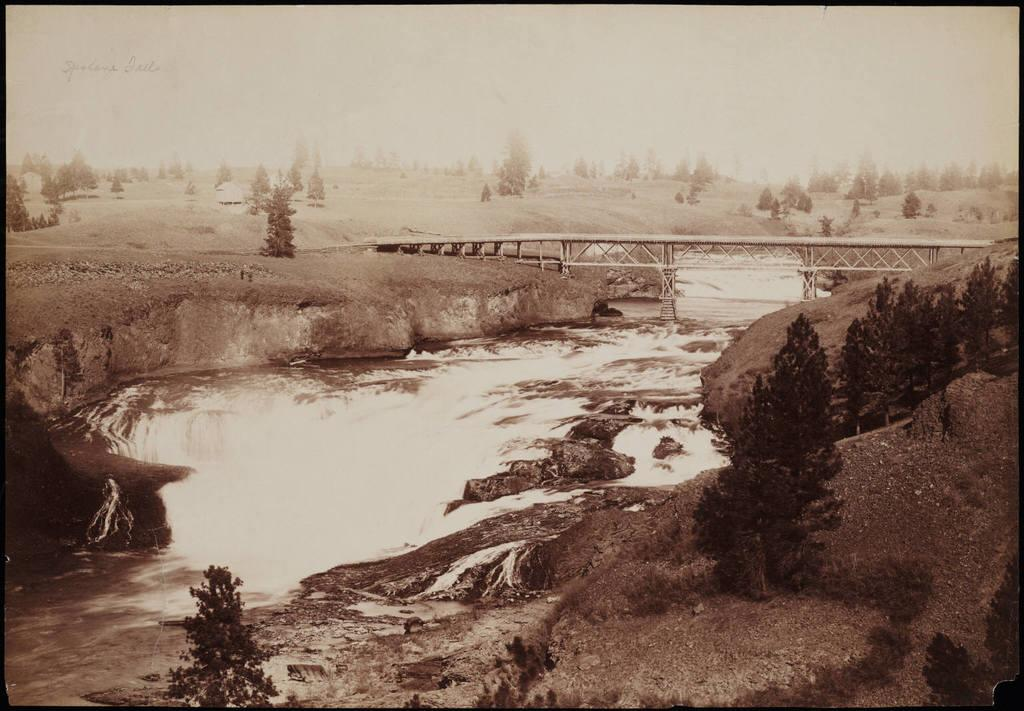What can be found at the bottom of the image? There are stones, plants, waves, and water visible at the bottom of the image. What is located in the middle of the image? There is a bridge in the middle of the image. What can be seen in the background of the image? Trees, text, land, and the sky are visible in the background of the image. Can you see a cub playing with a sail in the image? There is no cub or sail present in the image. How many times does the bridge twist in the image? The bridge does not twist in the image; it is a straight across the water. 